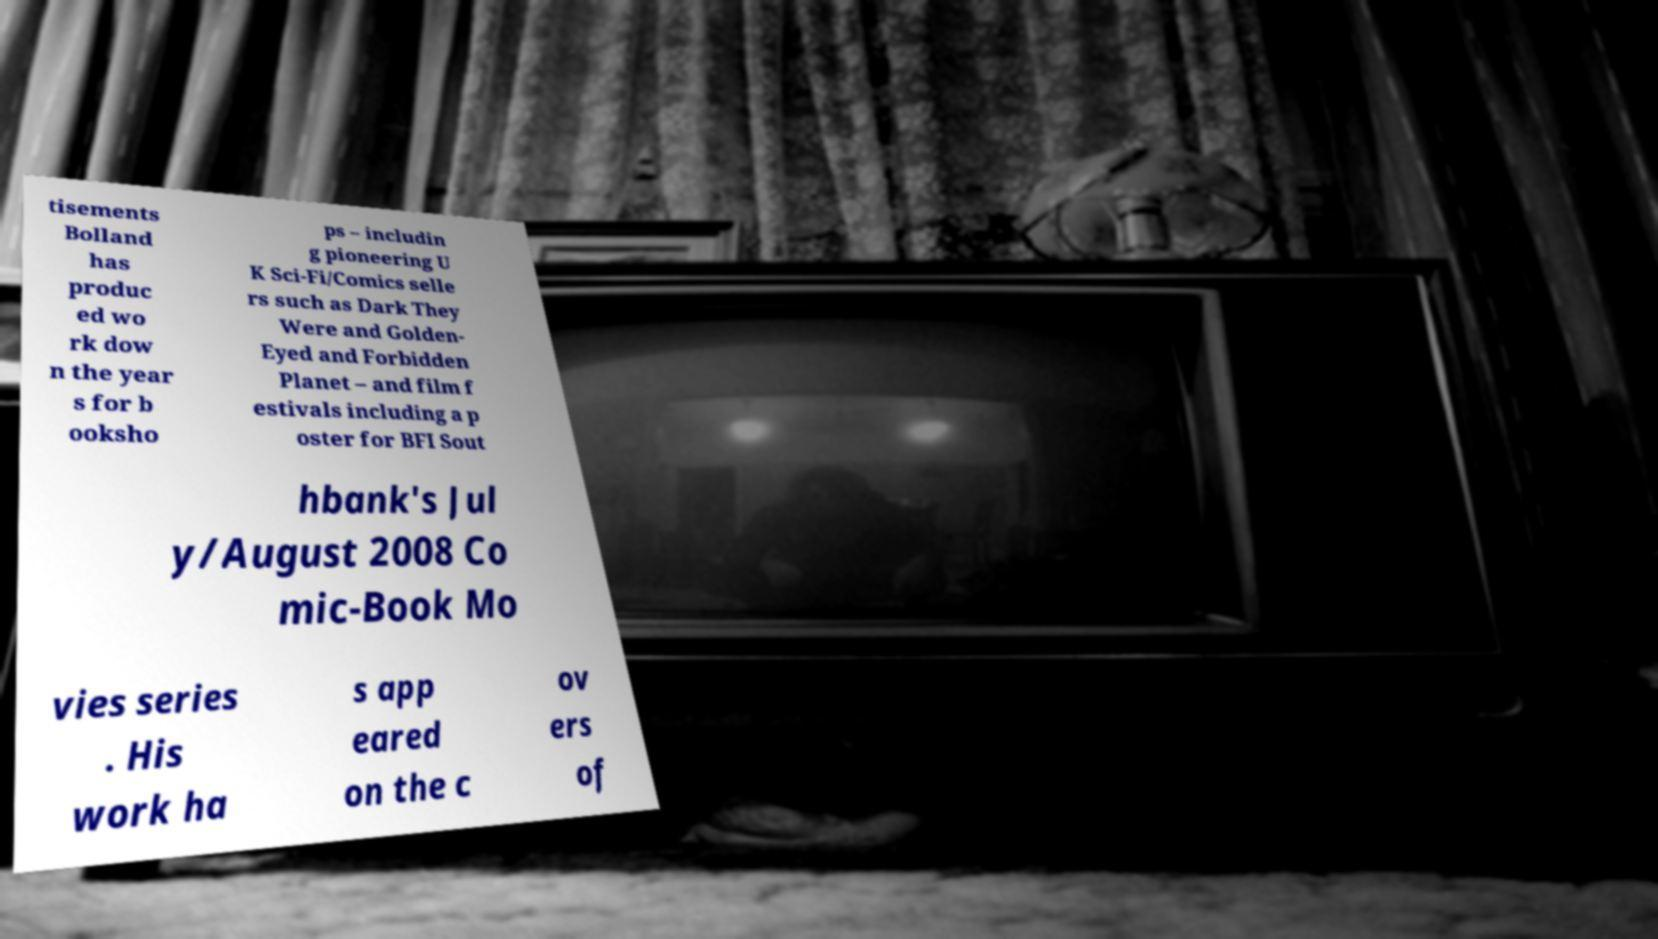Can you read and provide the text displayed in the image?This photo seems to have some interesting text. Can you extract and type it out for me? tisements Bolland has produc ed wo rk dow n the year s for b ooksho ps – includin g pioneering U K Sci-Fi/Comics selle rs such as Dark They Were and Golden- Eyed and Forbidden Planet – and film f estivals including a p oster for BFI Sout hbank's Jul y/August 2008 Co mic-Book Mo vies series . His work ha s app eared on the c ov ers of 